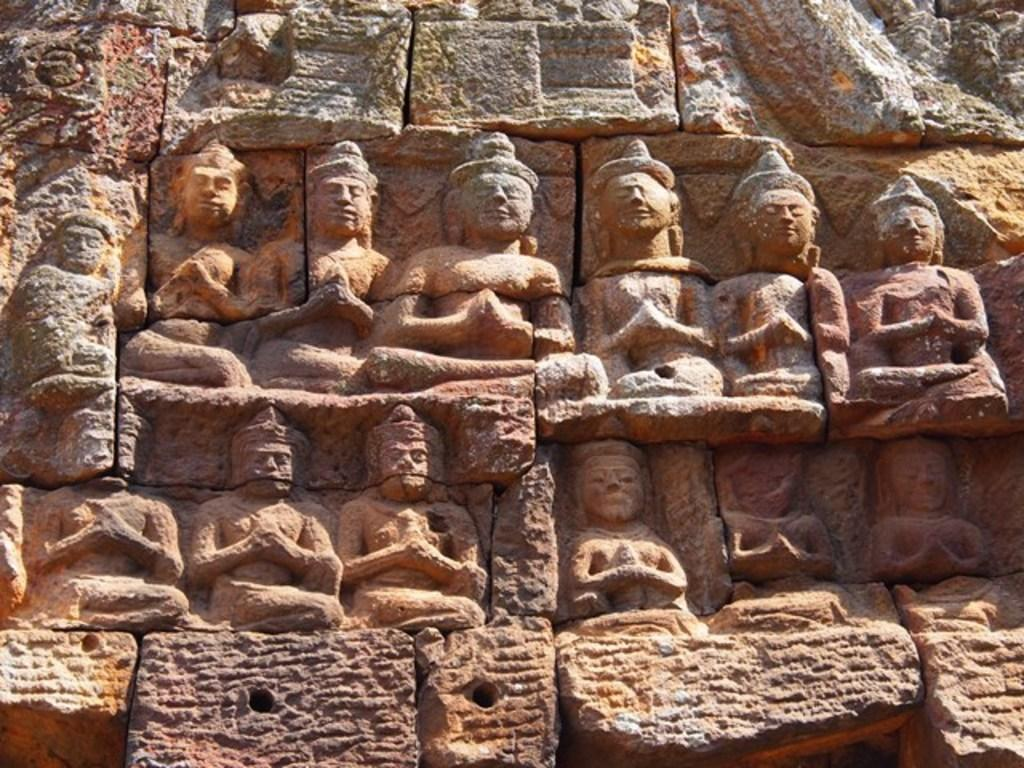What can be seen in the foreground of the image? There are sculptures in the foreground of the image. What is the sculptures resting on? The sculptures are on a stone. What type of cheese is being used to create the sculptures in the image? There is no cheese present in the image; the sculptures are made of a different material. 